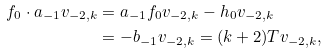Convert formula to latex. <formula><loc_0><loc_0><loc_500><loc_500>f _ { 0 } \cdot a _ { - 1 } v _ { - 2 , k } & = a _ { - 1 } f _ { 0 } v _ { - 2 , k } - h _ { 0 } v _ { - 2 , k } \\ & = - b _ { - 1 } v _ { - 2 , k } = ( k + 2 ) T v _ { - 2 , k } ,</formula> 